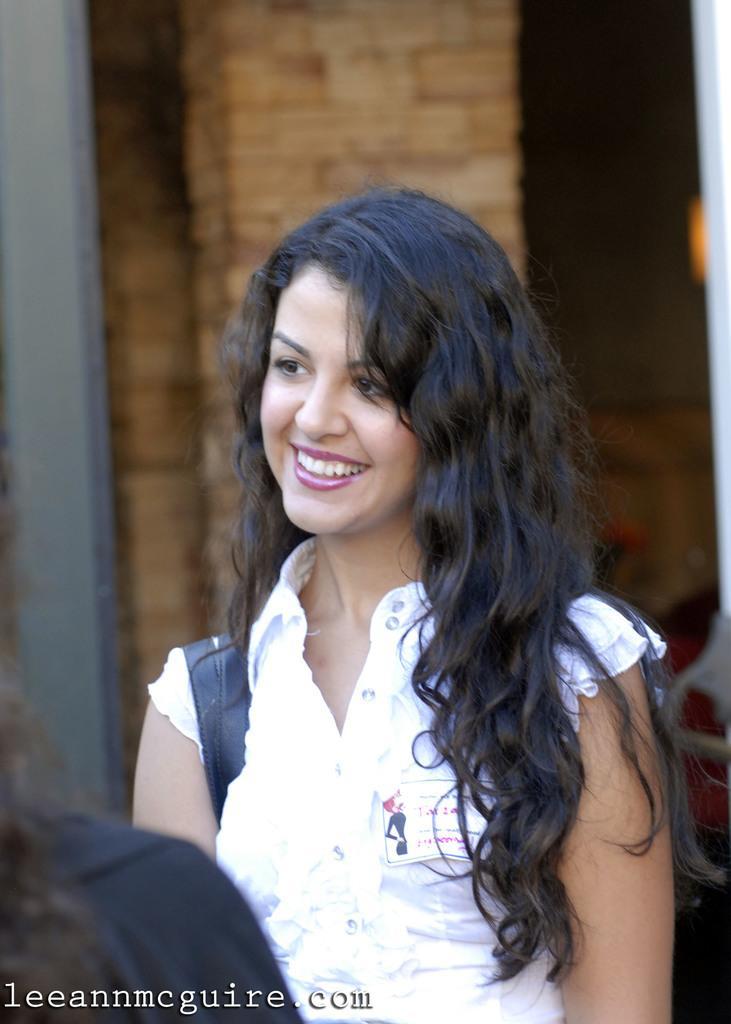Describe this image in one or two sentences. In this image I can see a woman. In the background, I can see the wall. 